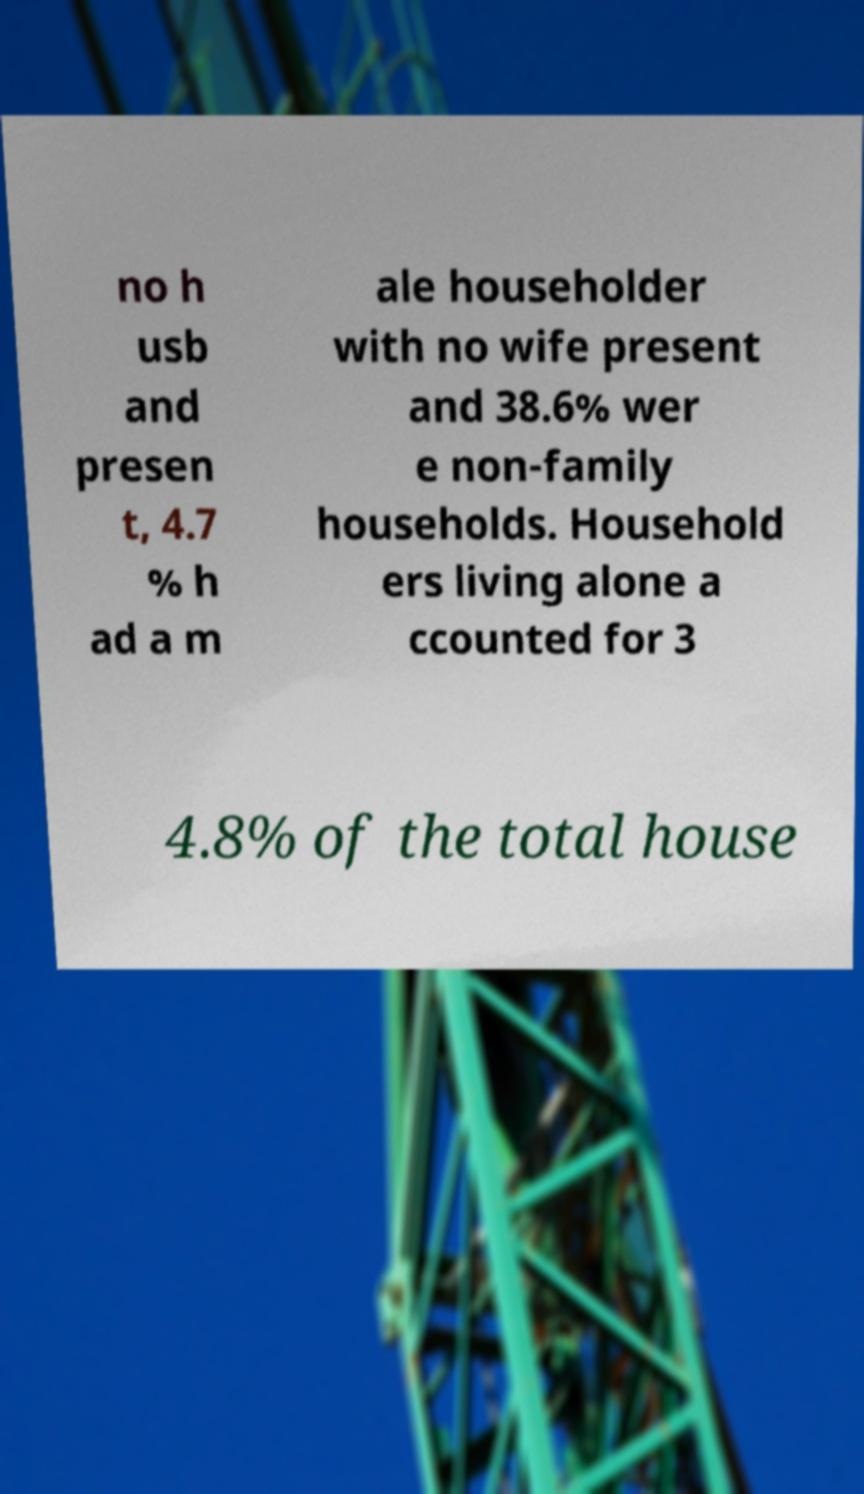Can you read and provide the text displayed in the image?This photo seems to have some interesting text. Can you extract and type it out for me? no h usb and presen t, 4.7 % h ad a m ale householder with no wife present and 38.6% wer e non-family households. Household ers living alone a ccounted for 3 4.8% of the total house 